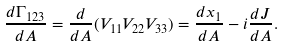Convert formula to latex. <formula><loc_0><loc_0><loc_500><loc_500>\frac { d \Gamma _ { 1 2 3 } } { d A } = \frac { d } { d A } ( V _ { 1 1 } V _ { 2 2 } V _ { 3 3 } ) = \frac { d x _ { 1 } } { d A } - i \frac { d J } { d A } .</formula> 